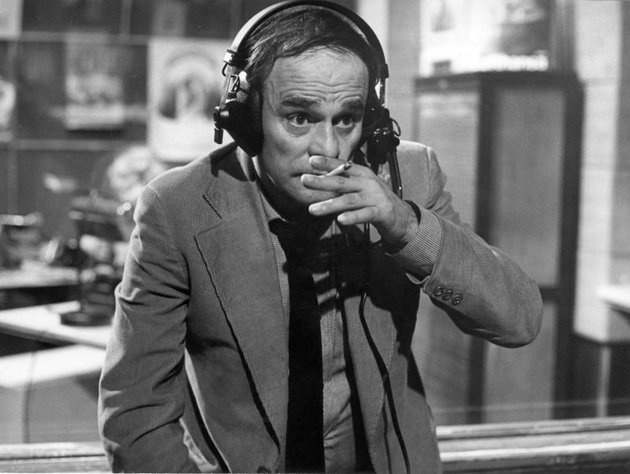Imagine this DJ works during a special event. What kind of event could it be, and how might it affect the atmosphere within the studio? Let's imagine this DJ is broadcasting live during a significant historical event, such as the moon landing in 1969. The atmosphere in the studio would be electric, filled with anticipation and excitement. The DJ would be providing real-time updates, engaging with expert guests, and perhaps even connecting live with people from different parts of the world. The posters around him might include images of spacecrafts and astronauts, adding to the thematic ambiance. The entire studio would be a hub of intense activity, with staff hustling to manage the influx of information and ensure a seamless broadcast. How might his interaction with the audience change during such a historic event? During a historic event like the moon landing, the DJ's interaction with the audience would be more dynamic and engaging. He might receive a wave of phone calls, messages, and social media interactions from listeners eager to share their thoughts and ask questions. The DJ would likely adopt a more interactive style, conducting live interviews, encouraging listener participation, and fostering a communal sense of witnessing history. His tone might be more enthusiastic and animated, capturing the collective excitement and wonder of the moment. 